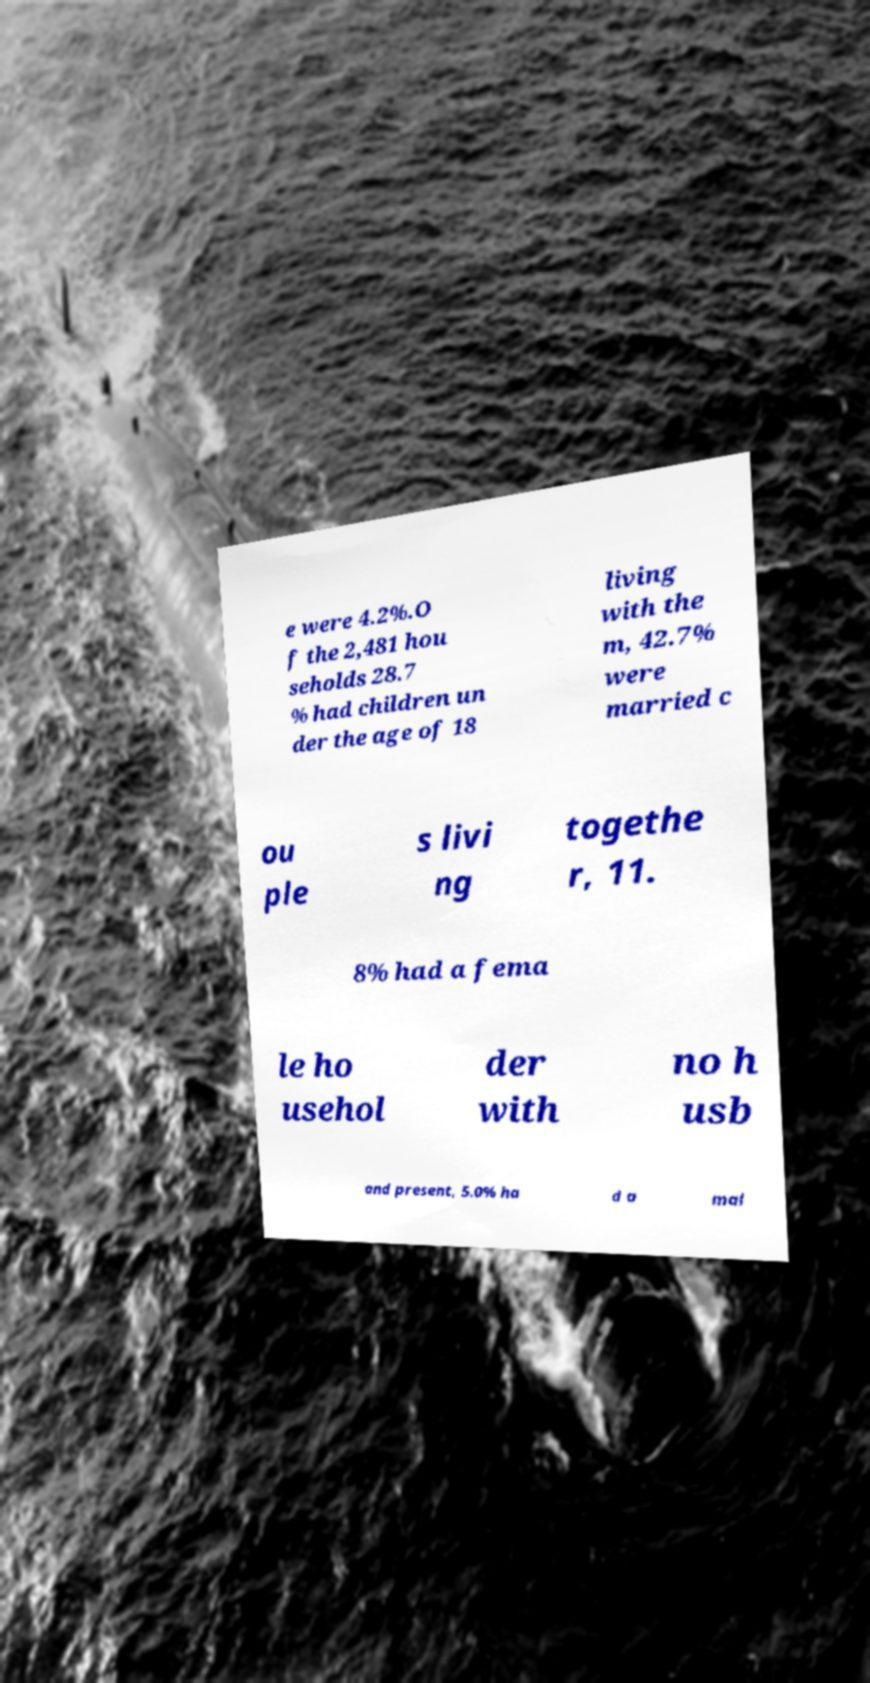There's text embedded in this image that I need extracted. Can you transcribe it verbatim? e were 4.2%.O f the 2,481 hou seholds 28.7 % had children un der the age of 18 living with the m, 42.7% were married c ou ple s livi ng togethe r, 11. 8% had a fema le ho usehol der with no h usb and present, 5.0% ha d a mal 